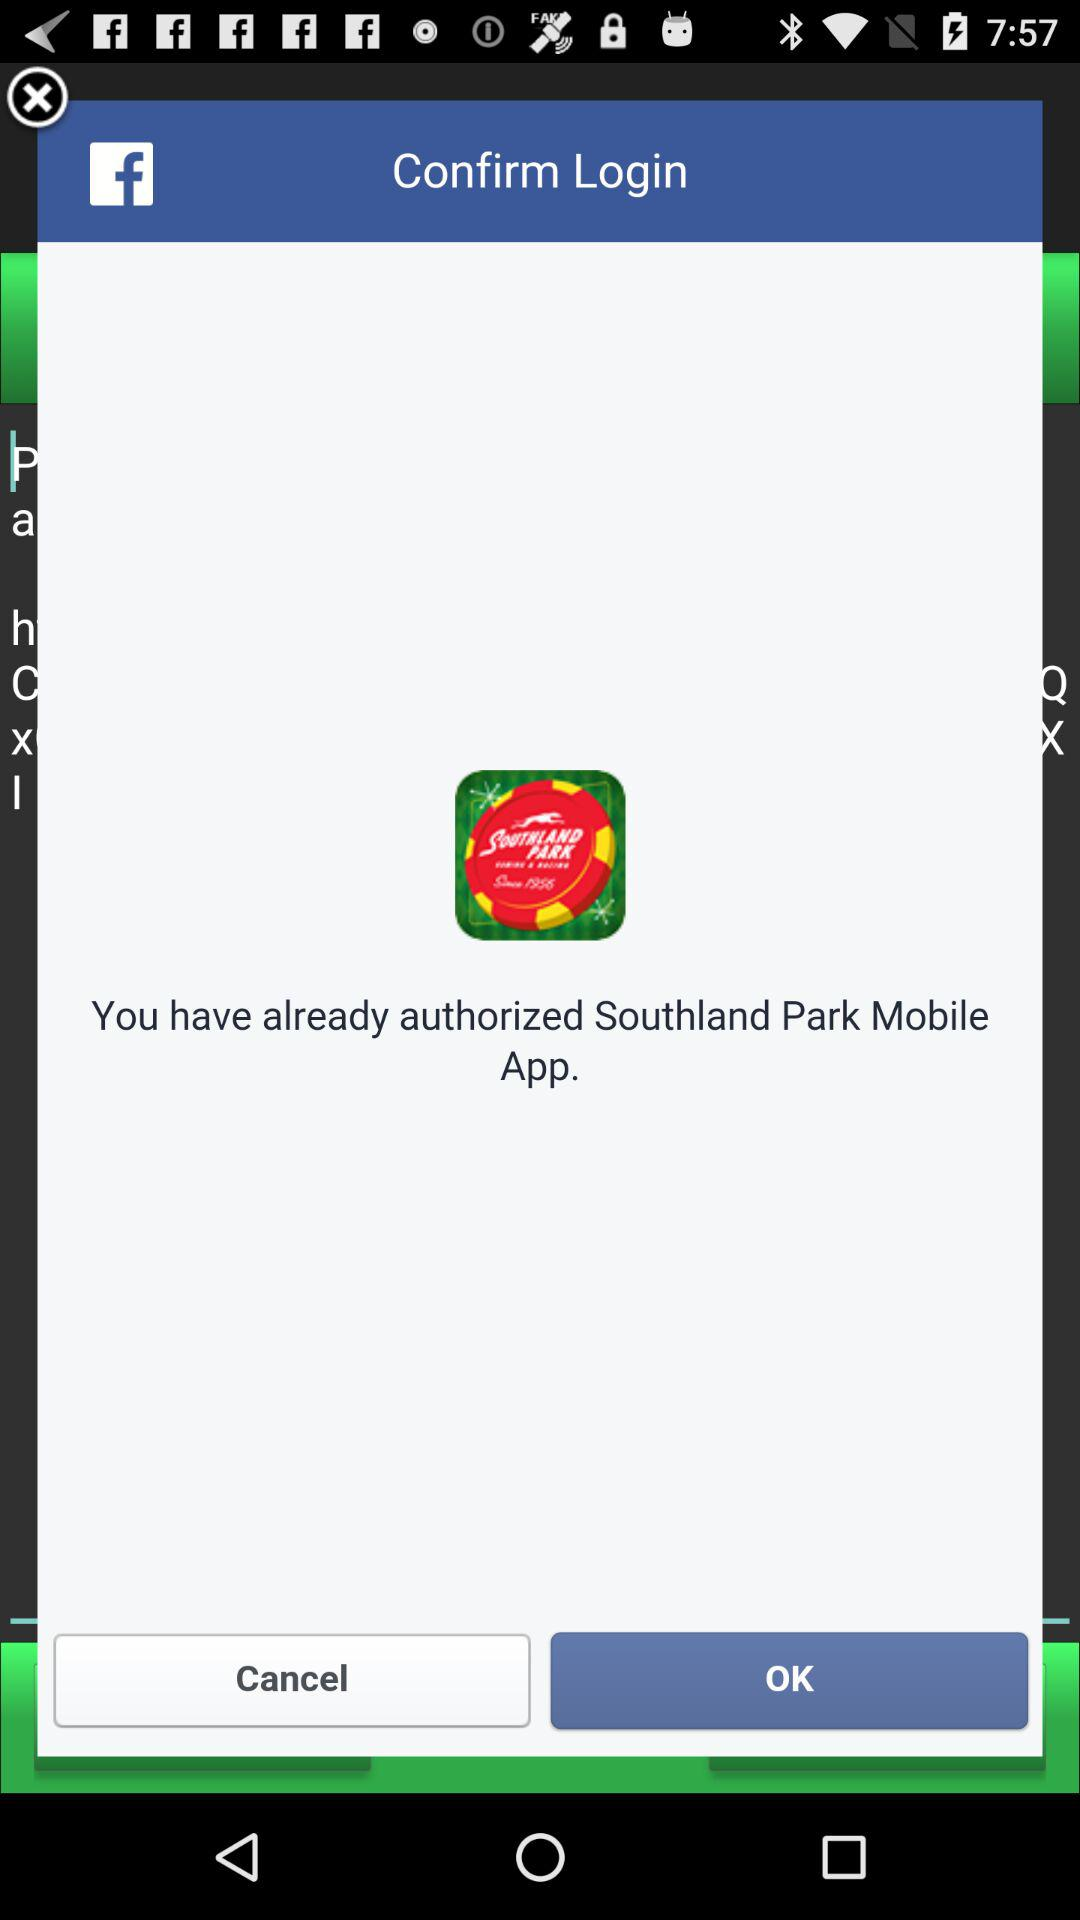What app is already authorized? The app that is already authorized is "Southland Park Mobile". 